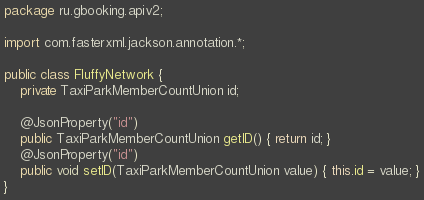Convert code to text. <code><loc_0><loc_0><loc_500><loc_500><_Java_>package ru.gbooking.apiv2;

import com.fasterxml.jackson.annotation.*;

public class FluffyNetwork {
    private TaxiParkMemberCountUnion id;

    @JsonProperty("id")
    public TaxiParkMemberCountUnion getID() { return id; }
    @JsonProperty("id")
    public void setID(TaxiParkMemberCountUnion value) { this.id = value; }
}
</code> 